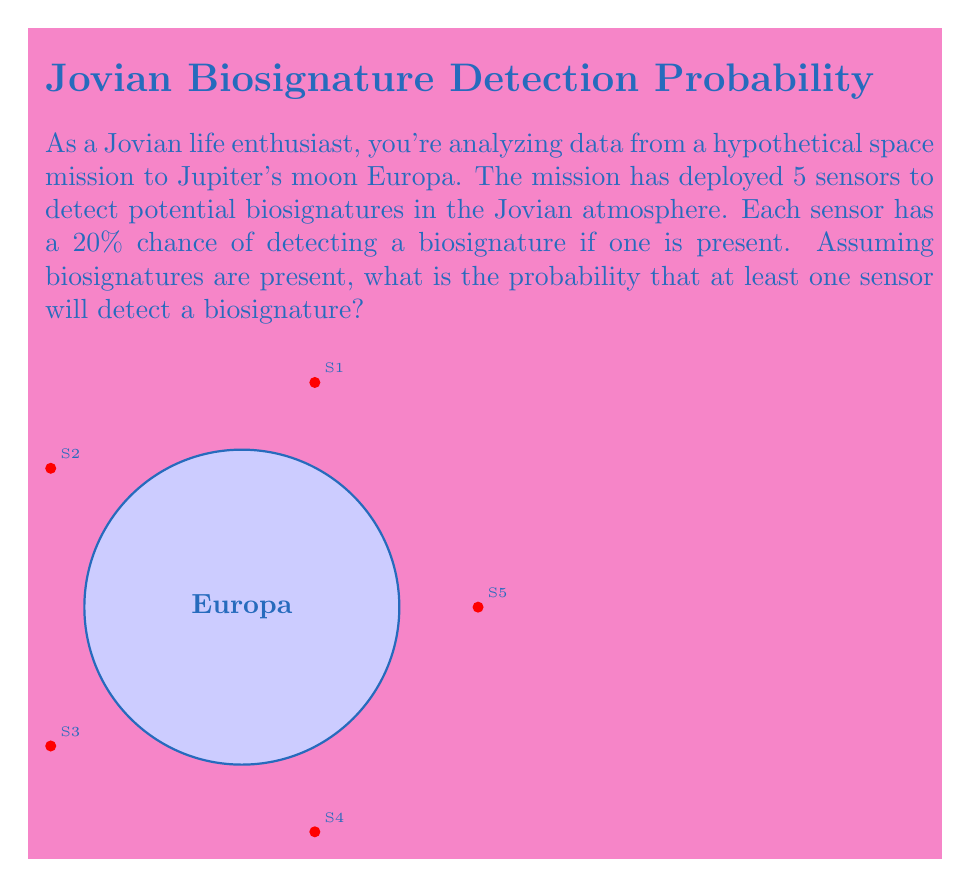Can you answer this question? Let's approach this step-by-step:

1) First, let's define our event:
   Let A be the event that at least one sensor detects a biosignature.

2) It's often easier to calculate the probability of the complement event:
   P(A) = 1 - P(not A)

3) The probability of not A is the probability that all sensors fail to detect a biosignature.

4) For each sensor:
   P(sensor fails to detect) = 1 - P(sensor detects) = 1 - 0.20 = 0.80

5) Since there are 5 independent sensors, and we need all of them to fail:
   P(not A) = $0.80^5$

6) Now we can calculate P(A):
   P(A) = 1 - P(not A) = 1 - $0.80^5$

7) Let's compute this:
   $0.80^5 = 0.32768$
   
   P(A) = 1 - 0.32768 = 0.67232

8) Therefore, the probability of at least one sensor detecting a biosignature is approximately 0.67232 or about 67.23%.
Answer: $$\text{P(at least one detection)} = 1 - 0.80^5 \approx 0.67232$$ 